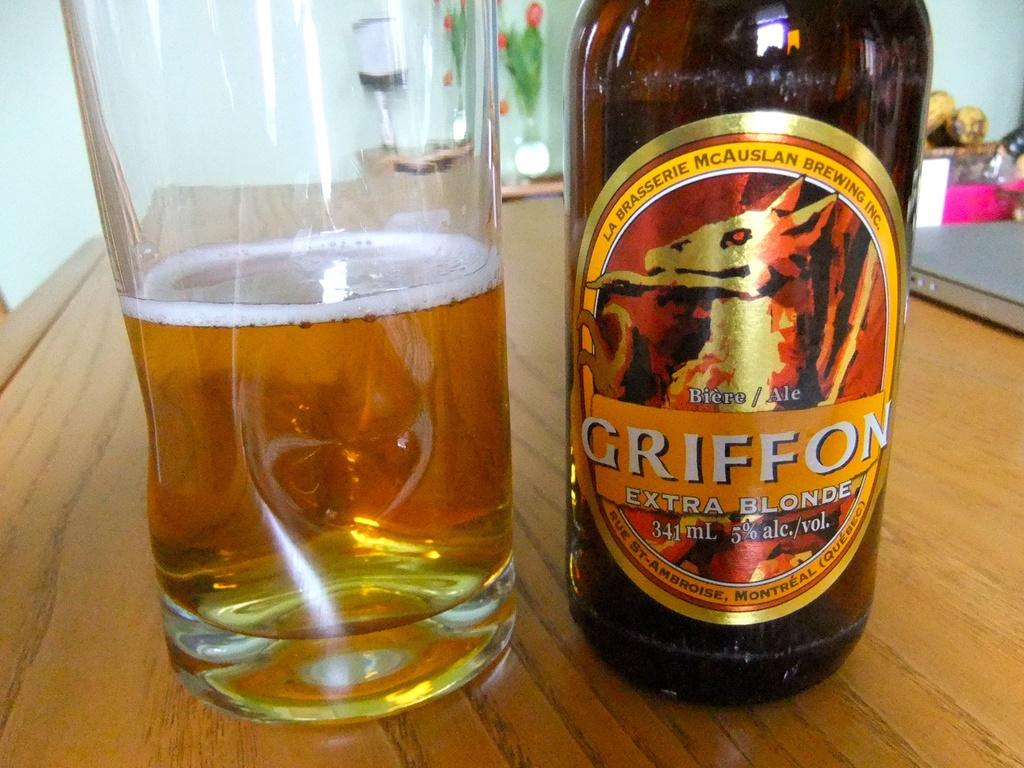<image>
Provide a brief description of the given image. A bottle labelled Griffon Extra Blonde stands next to a glass. 